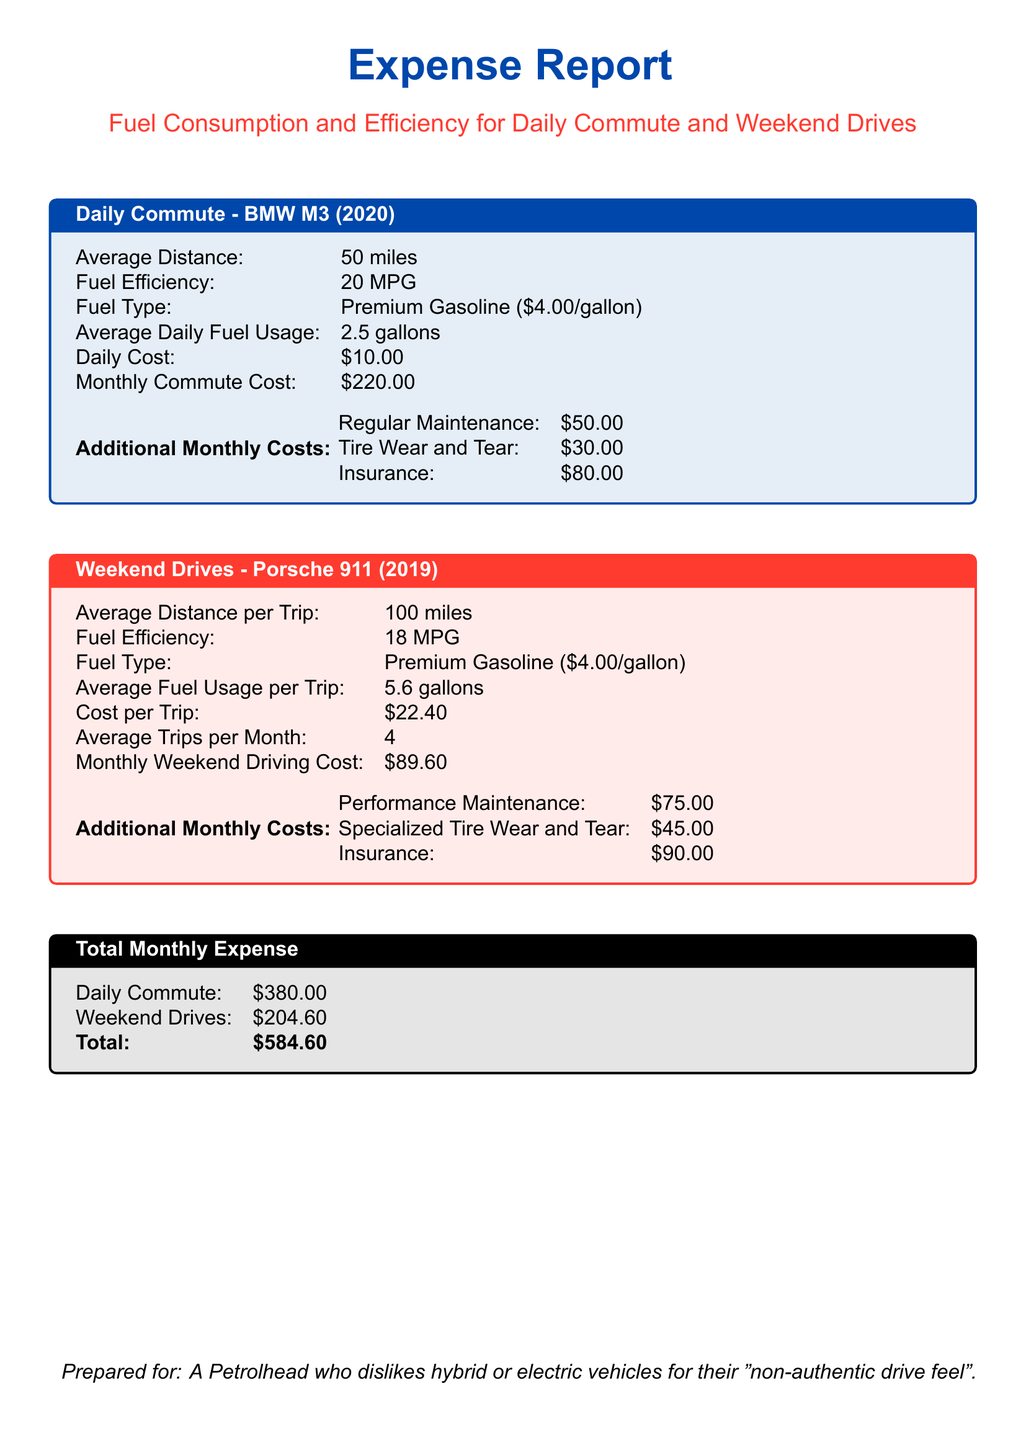What is the average distance for daily commute? The average distance for daily commute is stated in the document as 50 miles.
Answer: 50 miles What is the fuel efficiency of the BMW M3? The fuel efficiency of the BMW M3 is listed as 20 MPG.
Answer: 20 MPG How much does a trip in the Porsche 911 cost? The cost per trip in the Porsche 911 is found to be $22.40.
Answer: $22.40 What is the monthly cost for regular maintenance? The monthly cost for regular maintenance is mentioned as $50.00.
Answer: $50.00 What is the total monthly expense for both cars? The total monthly expense combines daily commute and weekend drives, totaling $584.60.
Answer: $584.60 What fuel type is used for both vehicles? The fuel type used for both vehicles is Premium Gasoline.
Answer: Premium Gasoline How many average trips are taken per month in the Porsche 911? The average number of trips taken per month in the Porsche 911 is given as 4.
Answer: 4 What is the cost for tire wear and tear on the BMW M3? The cost for tire wear and tear on the BMW M3 is stated as $30.00.
Answer: $30.00 What is the total monthly cost for weekend driving? The total monthly cost for weekend driving is stated as $204.60.
Answer: $204.60 